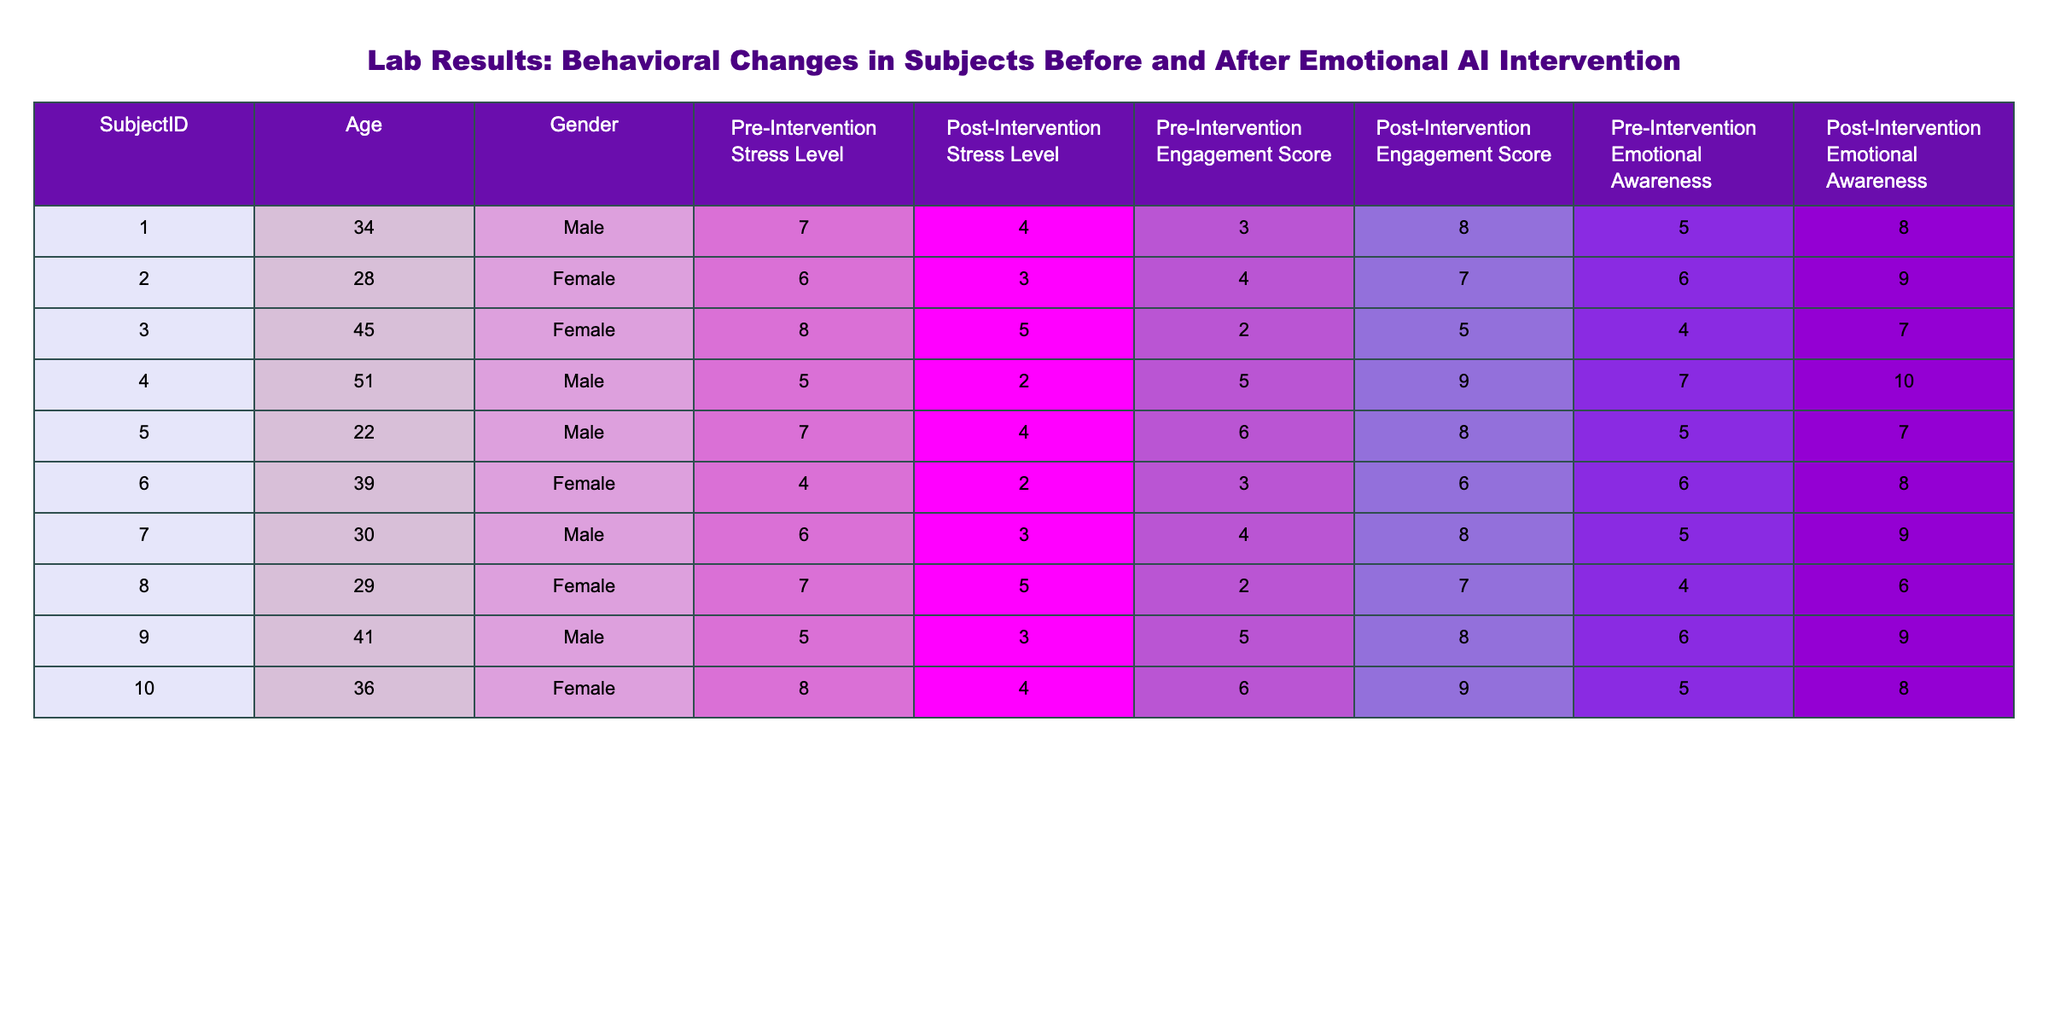What is the Pre-Intervention Stress Level of Subject 007? The table lists the Pre-Intervention Stress Level for each subject. For Subject 007, this value is 6.
Answer: 6 What was the Post-Intervention Engagement Score for the oldest subject? To find the oldest subject, I assess the ages provided in the table, identifying Subject 004 as the oldest (51 years). The Post-Intervention Engagement Score for this subject is 9.
Answer: 9 Is there a subject who had a lower Post-Intervention Stress Level than their Pre-Intervention Stress Level? By reviewing the table, I see that all subjects have lower values in their Post-Intervention Stress Level compared to their Pre-Intervention levels, thus confirming the statement is true.
Answer: Yes What is the average Pre-Intervention Emotional Awareness across all subjects? I sum the Pre-Intervention Emotional Awareness values (5 + 6 + 4 + 7 + 5 + 6 + 5 + 4 + 6 + 5 = 57), and then divide by the number of subjects (10). The average is 57/10 = 5.7.
Answer: 5.7 Which subject showed the greatest improvement in Engagement Score after the intervention? I calculate the difference between Pre- and Post-Intervention Engagement Scores for each subject. Subject 004 shows the highest improvement with a change of 4 (from 5 to 9).
Answer: Subject 004 Was the Pre-Intervention Stress Level of Subject 002 higher than 5? Looking at the Pre-Intervention Stress Level for Subject 002, which is 6, I confirm that this value is indeed higher than 5.
Answer: Yes What is the total decrease in Stress Levels for all subjects combined? I first find the total for Pre-Intervention Stress Levels (7 + 6 + 8 + 5 + 7 + 4 + 6 + 7 + 5 + 8 = 63) and the total for Post-Intervention Stress Levels (4 + 3 + 5 + 2 + 4 + 2 + 3 + 5 + 4 + 4 = 43). The total decrease is 63 - 43 = 20.
Answer: 20 How many subjects improved their Emotional Awareness score by at least 2 points? I evaluate the changes in Emotional Awareness scores post-intervention for each subject, confirming that Subjects 001, 002, 004, 006, 007, and 010 all improved by at least 2 points. This totals 6 subjects.
Answer: 6 What percentage of subjects had a Post-Intervention Stress Level of 3 or lower? There are 10 subjects in total. 4 of them (Subjects 002, 004, 006, and 007) had a Post-Intervention Stress Level of 3 or lower. The percentage is (4/10) * 100 = 40%.
Answer: 40% 